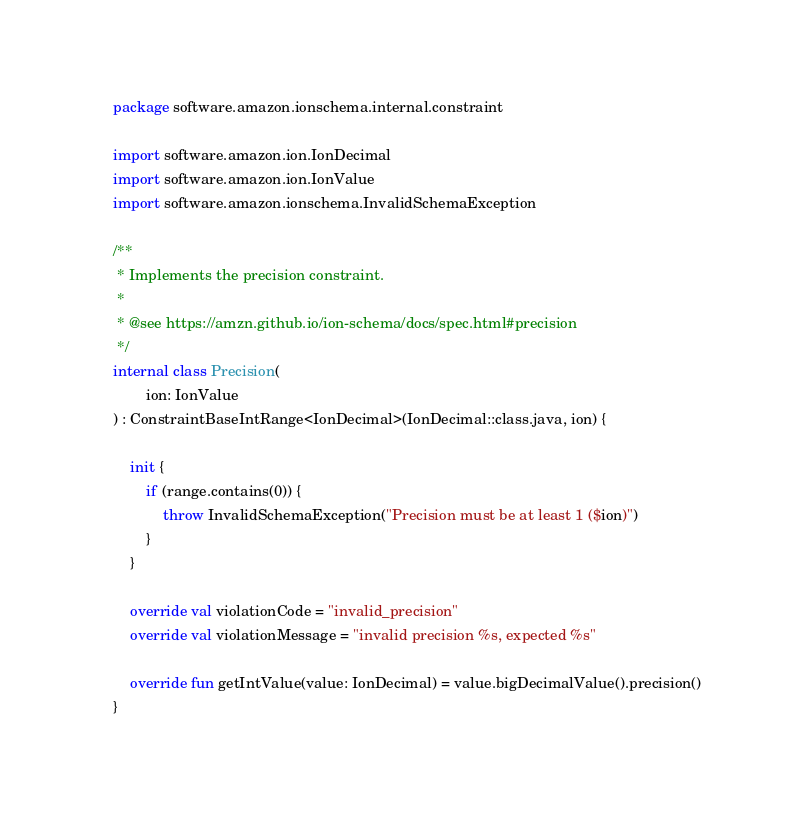<code> <loc_0><loc_0><loc_500><loc_500><_Kotlin_>package software.amazon.ionschema.internal.constraint

import software.amazon.ion.IonDecimal
import software.amazon.ion.IonValue
import software.amazon.ionschema.InvalidSchemaException

/**
 * Implements the precision constraint.
 *
 * @see https://amzn.github.io/ion-schema/docs/spec.html#precision
 */
internal class Precision(
        ion: IonValue
) : ConstraintBaseIntRange<IonDecimal>(IonDecimal::class.java, ion) {

    init {
        if (range.contains(0)) {
            throw InvalidSchemaException("Precision must be at least 1 ($ion)")
        }
    }

    override val violationCode = "invalid_precision"
    override val violationMessage = "invalid precision %s, expected %s"

    override fun getIntValue(value: IonDecimal) = value.bigDecimalValue().precision()
}

</code> 